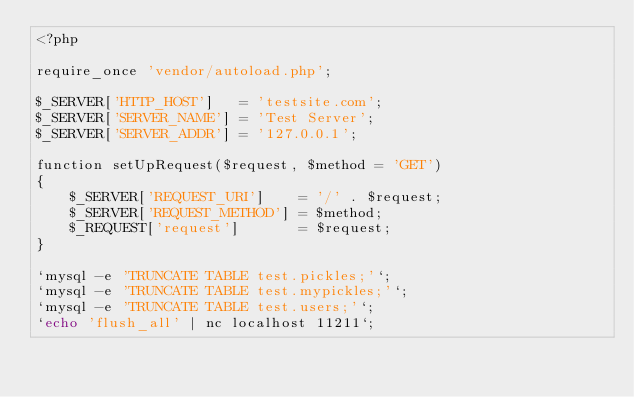Convert code to text. <code><loc_0><loc_0><loc_500><loc_500><_PHP_><?php

require_once 'vendor/autoload.php';

$_SERVER['HTTP_HOST']   = 'testsite.com';
$_SERVER['SERVER_NAME'] = 'Test Server';
$_SERVER['SERVER_ADDR'] = '127.0.0.1';

function setUpRequest($request, $method = 'GET')
{
    $_SERVER['REQUEST_URI']    = '/' . $request;
    $_SERVER['REQUEST_METHOD'] = $method;
    $_REQUEST['request']       = $request;
}

`mysql -e 'TRUNCATE TABLE test.pickles;'`;
`mysql -e 'TRUNCATE TABLE test.mypickles;'`;
`mysql -e 'TRUNCATE TABLE test.users;'`;
`echo 'flush_all' | nc localhost 11211`;

</code> 